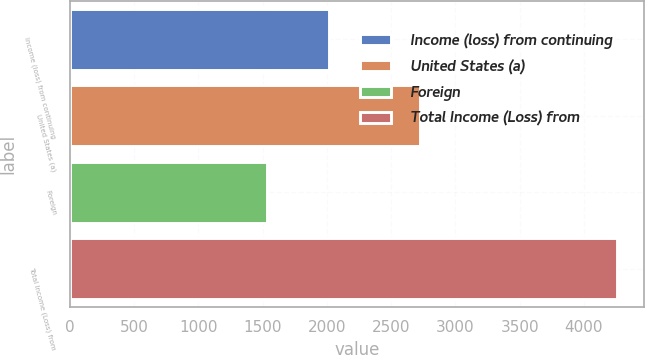Convert chart to OTSL. <chart><loc_0><loc_0><loc_500><loc_500><bar_chart><fcel>Income (loss) from continuing<fcel>United States (a)<fcel>Foreign<fcel>Total Income (Loss) from<nl><fcel>2015<fcel>2728<fcel>1530<fcel>4258<nl></chart> 